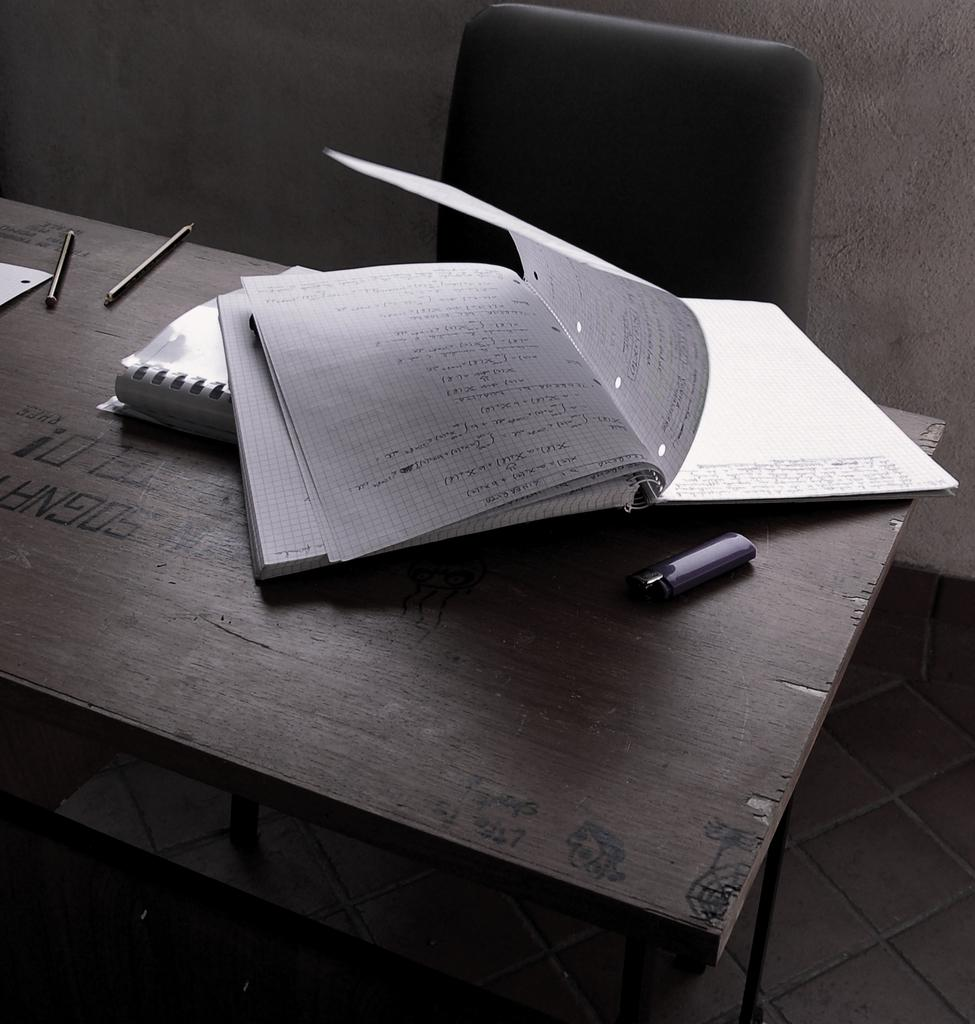Provide a one-sentence caption for the provided image. A notebook sits on a table with the word Sogna burned into it. 